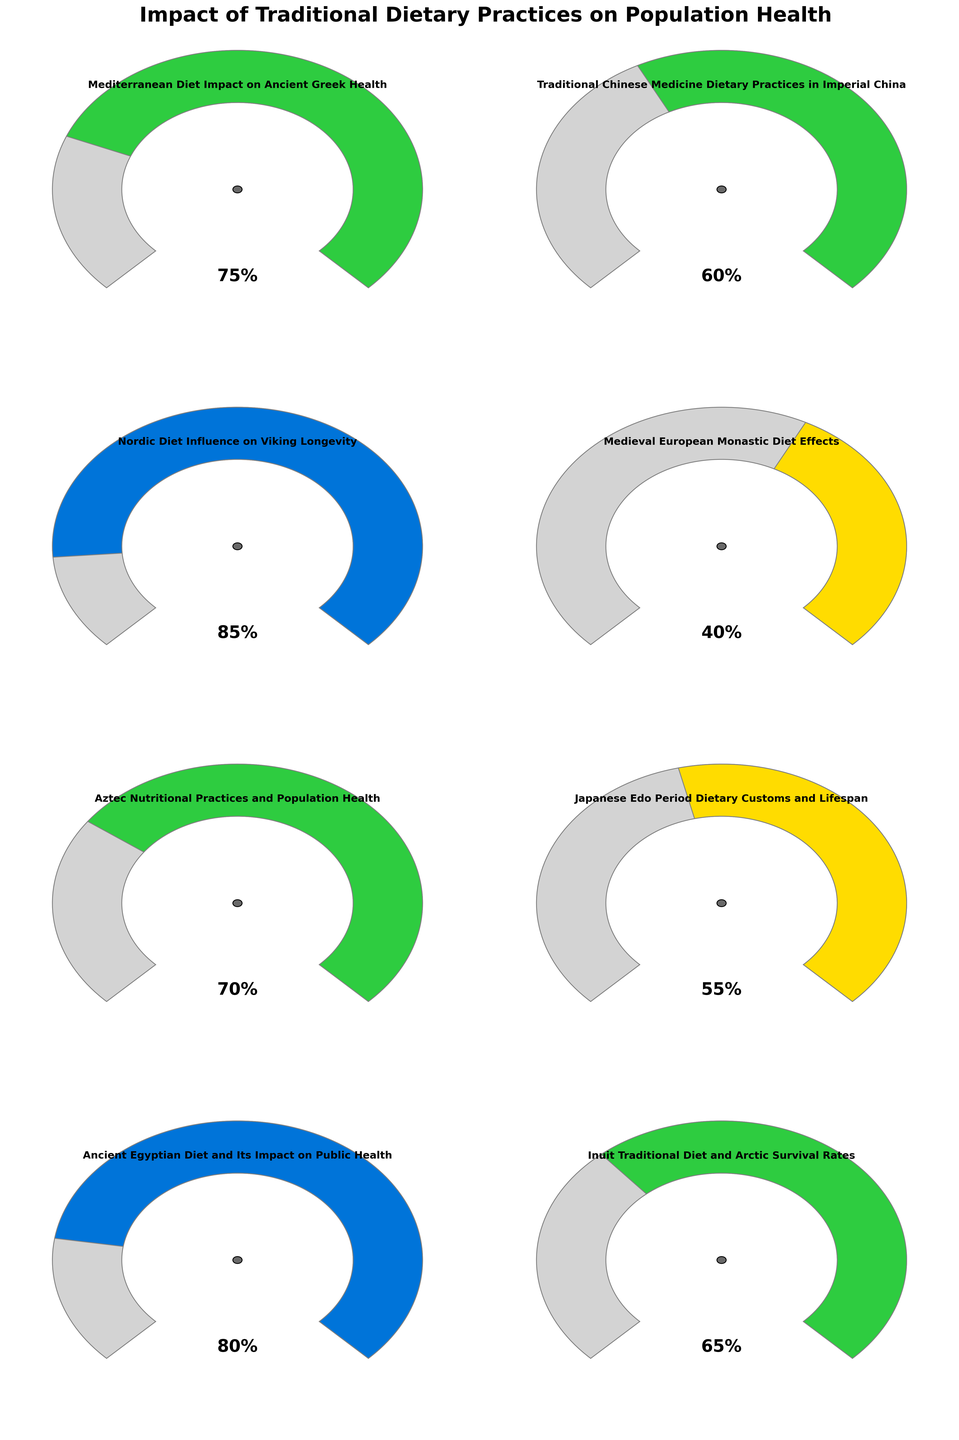what is the impact percentage of the Mediterranean Diet on Ancient Greek Health? The gauge for the Mediterranean Diet indicates the percentage value. The needle points to 75%.
Answer: 75% Which traditional diet shows the highest impact on population health? Compare all gauge values. The Nordic Diet Influence on Viking Longevity has the highest needle value at 85%.
Answer: Nordic Diet Influence on Viking Longevity Which traditional diet has the lowest impact on population health? Compare all gauge values. The Medieval European Monastic Diet Effects has the lowest needle value at 40%.
Answer: Medieval European Monastic Diet Effects What is the average impact percentage of the following diets: Mediterranean Diet, Traditional Chinese Medicine Dietary Practices, and Nordic Diet? Sum the values: 75 (Mediterranean) + 60 (Traditional Chinese) + 85 (Nordic) = 220. Divide by 3 to get the average: 220 / 3 = 73.33
Answer: 73.33 How does the impact of the Japanese Edo Period Dietary Customs on lifespan compare to the impact of Inuit Traditional Diet on Arctic Survival Rates? The gauge for Japanese Edo Period Dietary Customs is at 55%, and the gauge for Inuit Traditional Diet is at 65%. The Inuit Traditional Diet has a higher impact by 10% (65% - 55%).
Answer: Inuit Traditional Diet is 10% higher Which traditional diet has almost the same impact percentage as the Aztec Nutritional Practices? The Aztec Nutritional Practices have a value of 70%. The Japanese Edo Period Dietary Customs have a close value at 55%.
Answer: Japanese Edo Period Dietary Customs What's the range of impact percentages shown by the gauges? Identify the minimum and maximum values: 40% (Medieval European Monastic Diet) and 85% (Nordic Diet). The range is 85% - 40% = 45%.
Answer: 45% Among the listed dietary practices, identify those with an impact of 60% or higher. Examine each gauge, and list those with values equal to or above 60%. They are: Mediterranean Diet (75%), Traditional Chinese Medicine (60%), Nordic Diet (85%), Aztec Nutritional Practices (70%), Inuit Traditional Diet (65%), and Ancient Egyptian Diet (80%).
Answer: 6 dietary practices 